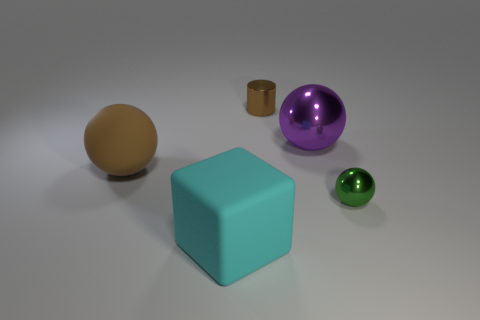What number of big balls have the same color as the small cylinder?
Provide a short and direct response. 1. What is the shape of the object that is both in front of the large matte ball and left of the green metallic object?
Your answer should be compact. Cube. What is the material of the thing that is in front of the tiny thing that is to the right of the tiny object behind the purple object?
Ensure brevity in your answer.  Rubber. Are there more cyan rubber objects that are behind the big cyan rubber cube than shiny cylinders left of the brown rubber thing?
Provide a succinct answer. No. How many other big brown balls are the same material as the big brown sphere?
Your answer should be compact. 0. Do the tiny object in front of the big purple sphere and the large object to the right of the tiny brown cylinder have the same shape?
Your answer should be compact. Yes. What color is the big object that is in front of the small green sphere?
Give a very brief answer. Cyan. Are there any small red things that have the same shape as the big metallic object?
Offer a very short reply. No. What material is the cylinder?
Offer a very short reply. Metal. What size is the ball that is both in front of the purple metal sphere and to the right of the brown rubber sphere?
Your response must be concise. Small. 